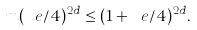<formula> <loc_0><loc_0><loc_500><loc_500>m ( \ e / 4 ) ^ { 2 d } \leq ( 1 + \ e / 4 ) ^ { 2 d } .</formula> 